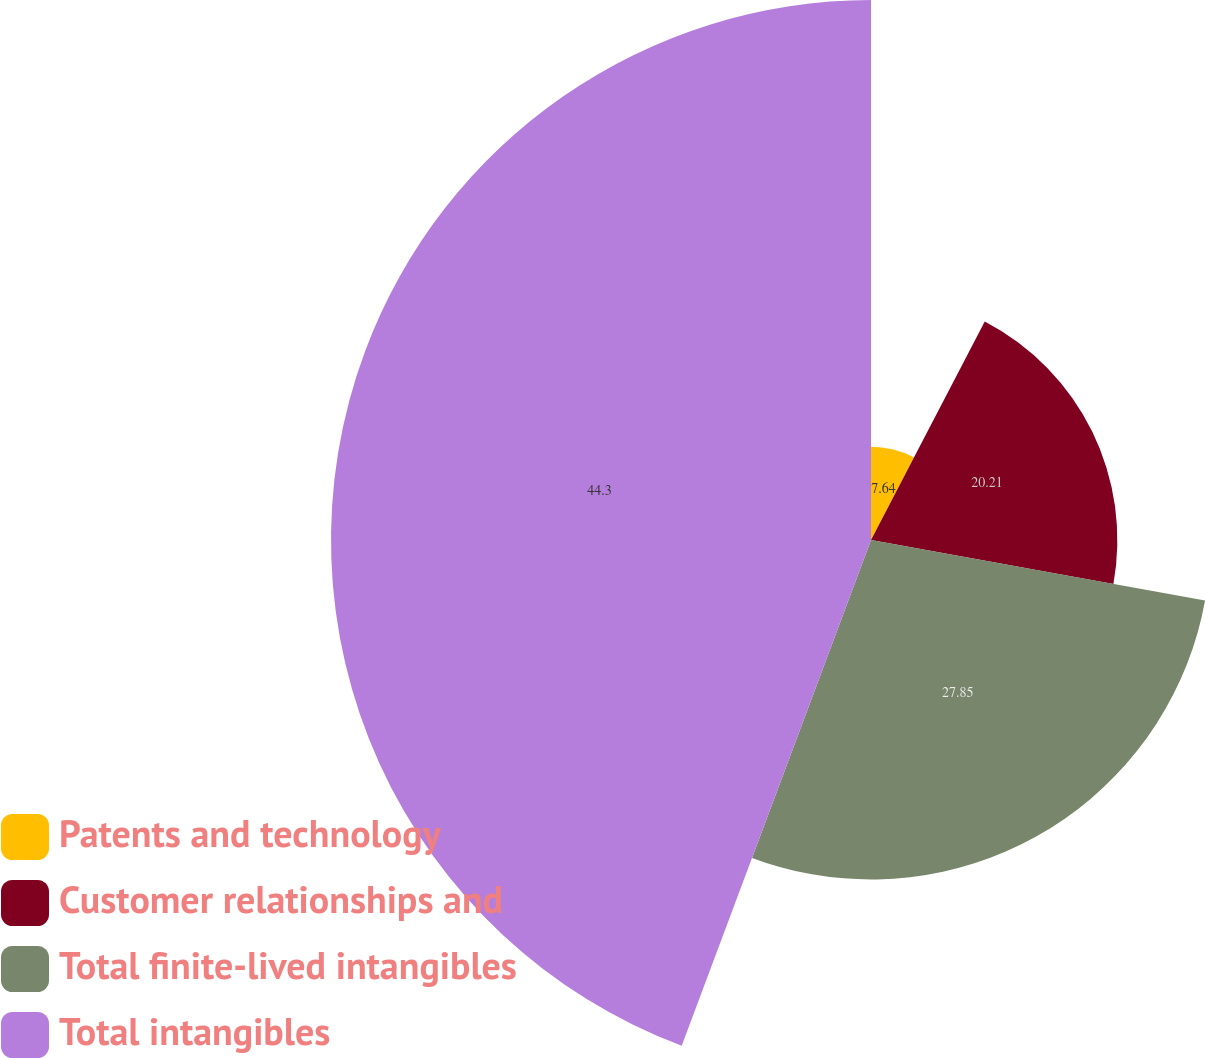Convert chart to OTSL. <chart><loc_0><loc_0><loc_500><loc_500><pie_chart><fcel>Patents and technology<fcel>Customer relationships and<fcel>Total finite-lived intangibles<fcel>Total intangibles<nl><fcel>7.64%<fcel>20.21%<fcel>27.85%<fcel>44.3%<nl></chart> 